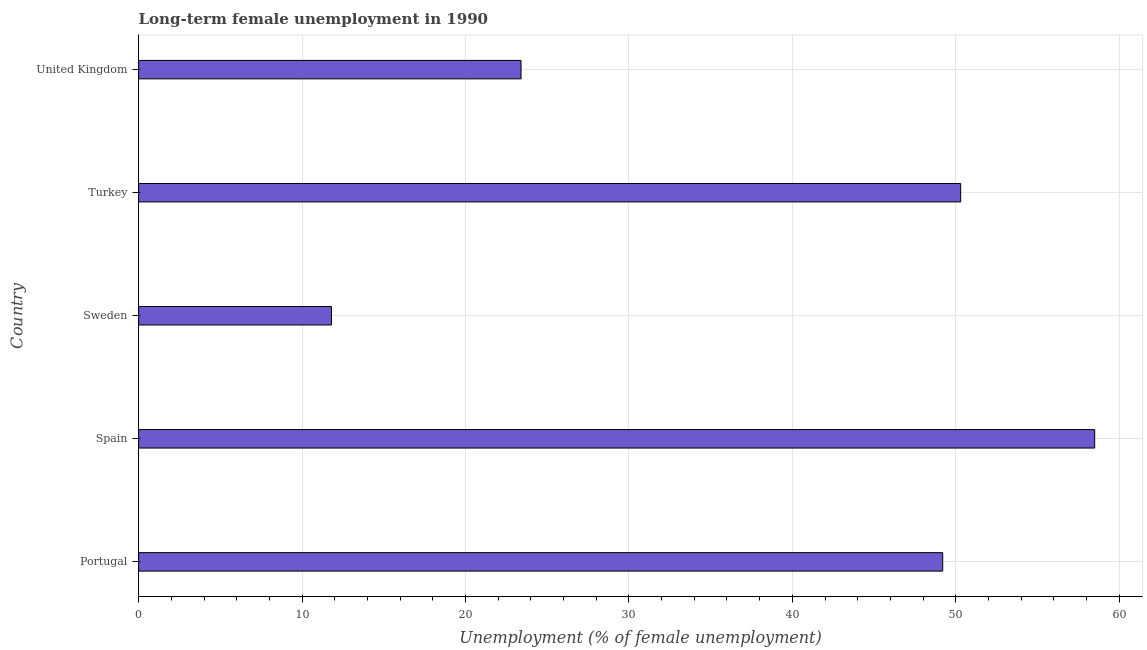Does the graph contain grids?
Provide a succinct answer. Yes. What is the title of the graph?
Your response must be concise. Long-term female unemployment in 1990. What is the label or title of the X-axis?
Your response must be concise. Unemployment (% of female unemployment). What is the label or title of the Y-axis?
Offer a very short reply. Country. What is the long-term female unemployment in Spain?
Your answer should be very brief. 58.5. Across all countries, what is the maximum long-term female unemployment?
Your answer should be very brief. 58.5. Across all countries, what is the minimum long-term female unemployment?
Your answer should be compact. 11.8. In which country was the long-term female unemployment maximum?
Your answer should be compact. Spain. In which country was the long-term female unemployment minimum?
Offer a terse response. Sweden. What is the sum of the long-term female unemployment?
Ensure brevity in your answer.  193.2. What is the average long-term female unemployment per country?
Keep it short and to the point. 38.64. What is the median long-term female unemployment?
Offer a terse response. 49.2. In how many countries, is the long-term female unemployment greater than 18 %?
Offer a terse response. 4. What is the ratio of the long-term female unemployment in Portugal to that in Sweden?
Offer a terse response. 4.17. Is the difference between the long-term female unemployment in Sweden and Turkey greater than the difference between any two countries?
Provide a succinct answer. No. Is the sum of the long-term female unemployment in Portugal and Turkey greater than the maximum long-term female unemployment across all countries?
Your response must be concise. Yes. What is the difference between the highest and the lowest long-term female unemployment?
Your response must be concise. 46.7. In how many countries, is the long-term female unemployment greater than the average long-term female unemployment taken over all countries?
Offer a terse response. 3. What is the difference between two consecutive major ticks on the X-axis?
Provide a short and direct response. 10. What is the Unemployment (% of female unemployment) of Portugal?
Provide a short and direct response. 49.2. What is the Unemployment (% of female unemployment) in Spain?
Your response must be concise. 58.5. What is the Unemployment (% of female unemployment) of Sweden?
Ensure brevity in your answer.  11.8. What is the Unemployment (% of female unemployment) of Turkey?
Give a very brief answer. 50.3. What is the Unemployment (% of female unemployment) in United Kingdom?
Your answer should be compact. 23.4. What is the difference between the Unemployment (% of female unemployment) in Portugal and Spain?
Offer a terse response. -9.3. What is the difference between the Unemployment (% of female unemployment) in Portugal and Sweden?
Your answer should be compact. 37.4. What is the difference between the Unemployment (% of female unemployment) in Portugal and Turkey?
Your answer should be very brief. -1.1. What is the difference between the Unemployment (% of female unemployment) in Portugal and United Kingdom?
Your response must be concise. 25.8. What is the difference between the Unemployment (% of female unemployment) in Spain and Sweden?
Keep it short and to the point. 46.7. What is the difference between the Unemployment (% of female unemployment) in Spain and Turkey?
Provide a succinct answer. 8.2. What is the difference between the Unemployment (% of female unemployment) in Spain and United Kingdom?
Keep it short and to the point. 35.1. What is the difference between the Unemployment (% of female unemployment) in Sweden and Turkey?
Your response must be concise. -38.5. What is the difference between the Unemployment (% of female unemployment) in Turkey and United Kingdom?
Provide a short and direct response. 26.9. What is the ratio of the Unemployment (% of female unemployment) in Portugal to that in Spain?
Give a very brief answer. 0.84. What is the ratio of the Unemployment (% of female unemployment) in Portugal to that in Sweden?
Keep it short and to the point. 4.17. What is the ratio of the Unemployment (% of female unemployment) in Portugal to that in Turkey?
Offer a very short reply. 0.98. What is the ratio of the Unemployment (% of female unemployment) in Portugal to that in United Kingdom?
Your answer should be very brief. 2.1. What is the ratio of the Unemployment (% of female unemployment) in Spain to that in Sweden?
Offer a terse response. 4.96. What is the ratio of the Unemployment (% of female unemployment) in Spain to that in Turkey?
Provide a short and direct response. 1.16. What is the ratio of the Unemployment (% of female unemployment) in Sweden to that in Turkey?
Offer a very short reply. 0.23. What is the ratio of the Unemployment (% of female unemployment) in Sweden to that in United Kingdom?
Your answer should be very brief. 0.5. What is the ratio of the Unemployment (% of female unemployment) in Turkey to that in United Kingdom?
Give a very brief answer. 2.15. 